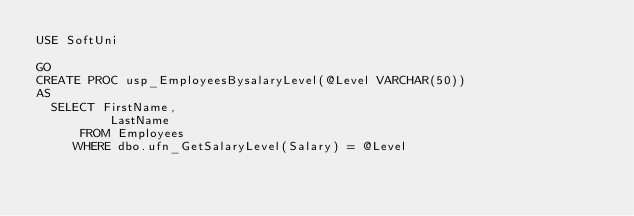<code> <loc_0><loc_0><loc_500><loc_500><_SQL_>USE SoftUni

GO
CREATE PROC usp_EmployeesBysalaryLevel(@Level VARCHAR(50))
AS
	SELECT FirstName,
	        LastName
      FROM Employees
     WHERE dbo.ufn_GetSalaryLevel(Salary) = @Level</code> 